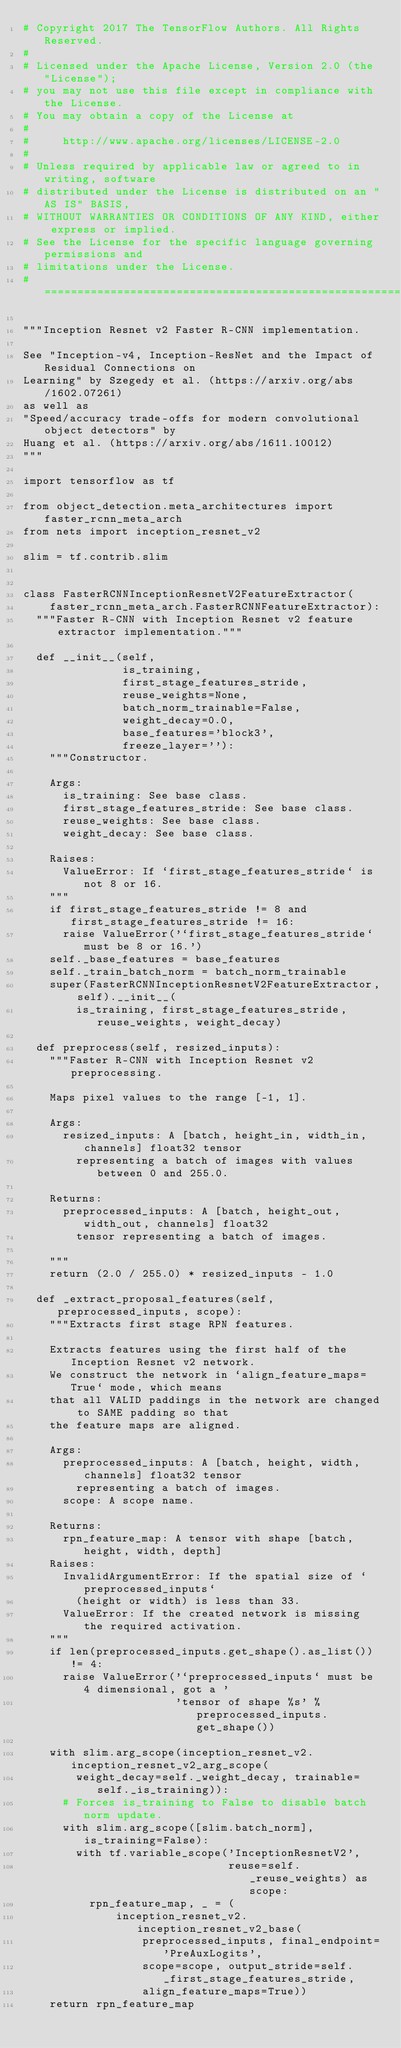<code> <loc_0><loc_0><loc_500><loc_500><_Python_># Copyright 2017 The TensorFlow Authors. All Rights Reserved.
#
# Licensed under the Apache License, Version 2.0 (the "License");
# you may not use this file except in compliance with the License.
# You may obtain a copy of the License at
#
#     http://www.apache.org/licenses/LICENSE-2.0
#
# Unless required by applicable law or agreed to in writing, software
# distributed under the License is distributed on an "AS IS" BASIS,
# WITHOUT WARRANTIES OR CONDITIONS OF ANY KIND, either express or implied.
# See the License for the specific language governing permissions and
# limitations under the License.
# ==============================================================================

"""Inception Resnet v2 Faster R-CNN implementation.

See "Inception-v4, Inception-ResNet and the Impact of Residual Connections on
Learning" by Szegedy et al. (https://arxiv.org/abs/1602.07261)
as well as
"Speed/accuracy trade-offs for modern convolutional object detectors" by
Huang et al. (https://arxiv.org/abs/1611.10012)
"""

import tensorflow as tf

from object_detection.meta_architectures import faster_rcnn_meta_arch
from nets import inception_resnet_v2

slim = tf.contrib.slim


class FasterRCNNInceptionResnetV2FeatureExtractor(
    faster_rcnn_meta_arch.FasterRCNNFeatureExtractor):
  """Faster R-CNN with Inception Resnet v2 feature extractor implementation."""

  def __init__(self,
               is_training,
               first_stage_features_stride,
               reuse_weights=None,
               batch_norm_trainable=False,
               weight_decay=0.0,
               base_features='block3',
               freeze_layer=''):
    """Constructor.

    Args:
      is_training: See base class.
      first_stage_features_stride: See base class.
      reuse_weights: See base class.
      weight_decay: See base class.

    Raises:
      ValueError: If `first_stage_features_stride` is not 8 or 16.
    """
    if first_stage_features_stride != 8 and first_stage_features_stride != 16:
      raise ValueError('`first_stage_features_stride` must be 8 or 16.')
    self._base_features = base_features
    self._train_batch_norm = batch_norm_trainable
    super(FasterRCNNInceptionResnetV2FeatureExtractor, self).__init__(
        is_training, first_stage_features_stride, reuse_weights, weight_decay)

  def preprocess(self, resized_inputs):
    """Faster R-CNN with Inception Resnet v2 preprocessing.

    Maps pixel values to the range [-1, 1].

    Args:
      resized_inputs: A [batch, height_in, width_in, channels] float32 tensor
        representing a batch of images with values between 0 and 255.0.

    Returns:
      preprocessed_inputs: A [batch, height_out, width_out, channels] float32
        tensor representing a batch of images.

    """
    return (2.0 / 255.0) * resized_inputs - 1.0

  def _extract_proposal_features(self, preprocessed_inputs, scope):
    """Extracts first stage RPN features.

    Extracts features using the first half of the Inception Resnet v2 network.
    We construct the network in `align_feature_maps=True` mode, which means
    that all VALID paddings in the network are changed to SAME padding so that
    the feature maps are aligned.

    Args:
      preprocessed_inputs: A [batch, height, width, channels] float32 tensor
        representing a batch of images.
      scope: A scope name.

    Returns:
      rpn_feature_map: A tensor with shape [batch, height, width, depth]
    Raises:
      InvalidArgumentError: If the spatial size of `preprocessed_inputs`
        (height or width) is less than 33.
      ValueError: If the created network is missing the required activation.
    """
    if len(preprocessed_inputs.get_shape().as_list()) != 4:
      raise ValueError('`preprocessed_inputs` must be 4 dimensional, got a '
                       'tensor of shape %s' % preprocessed_inputs.get_shape())

    with slim.arg_scope(inception_resnet_v2.inception_resnet_v2_arg_scope(
        weight_decay=self._weight_decay, trainable=self._is_training)):
      # Forces is_training to False to disable batch norm update.
      with slim.arg_scope([slim.batch_norm], is_training=False):
        with tf.variable_scope('InceptionResnetV2',
                               reuse=self._reuse_weights) as scope:
          rpn_feature_map, _ = (
              inception_resnet_v2.inception_resnet_v2_base(
                  preprocessed_inputs, final_endpoint='PreAuxLogits',
                  scope=scope, output_stride=self._first_stage_features_stride,
                  align_feature_maps=True))
    return rpn_feature_map
</code> 